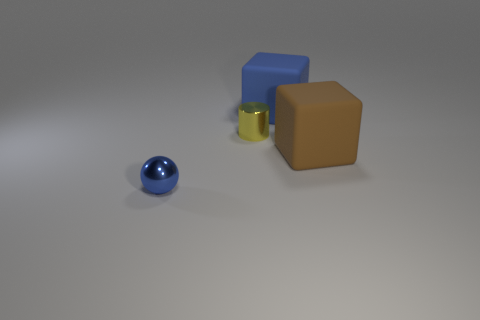Add 4 tiny shiny cylinders. How many objects exist? 8 Subtract all spheres. How many objects are left? 3 Add 2 tiny spheres. How many tiny spheres exist? 3 Subtract 0 blue cylinders. How many objects are left? 4 Subtract all red objects. Subtract all tiny blue balls. How many objects are left? 3 Add 2 tiny yellow shiny things. How many tiny yellow shiny things are left? 3 